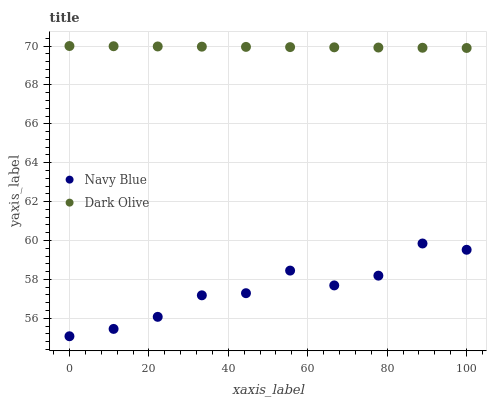Does Navy Blue have the minimum area under the curve?
Answer yes or no. Yes. Does Dark Olive have the maximum area under the curve?
Answer yes or no. Yes. Does Dark Olive have the minimum area under the curve?
Answer yes or no. No. Is Dark Olive the smoothest?
Answer yes or no. Yes. Is Navy Blue the roughest?
Answer yes or no. Yes. Is Dark Olive the roughest?
Answer yes or no. No. Does Navy Blue have the lowest value?
Answer yes or no. Yes. Does Dark Olive have the lowest value?
Answer yes or no. No. Does Dark Olive have the highest value?
Answer yes or no. Yes. Is Navy Blue less than Dark Olive?
Answer yes or no. Yes. Is Dark Olive greater than Navy Blue?
Answer yes or no. Yes. Does Navy Blue intersect Dark Olive?
Answer yes or no. No. 